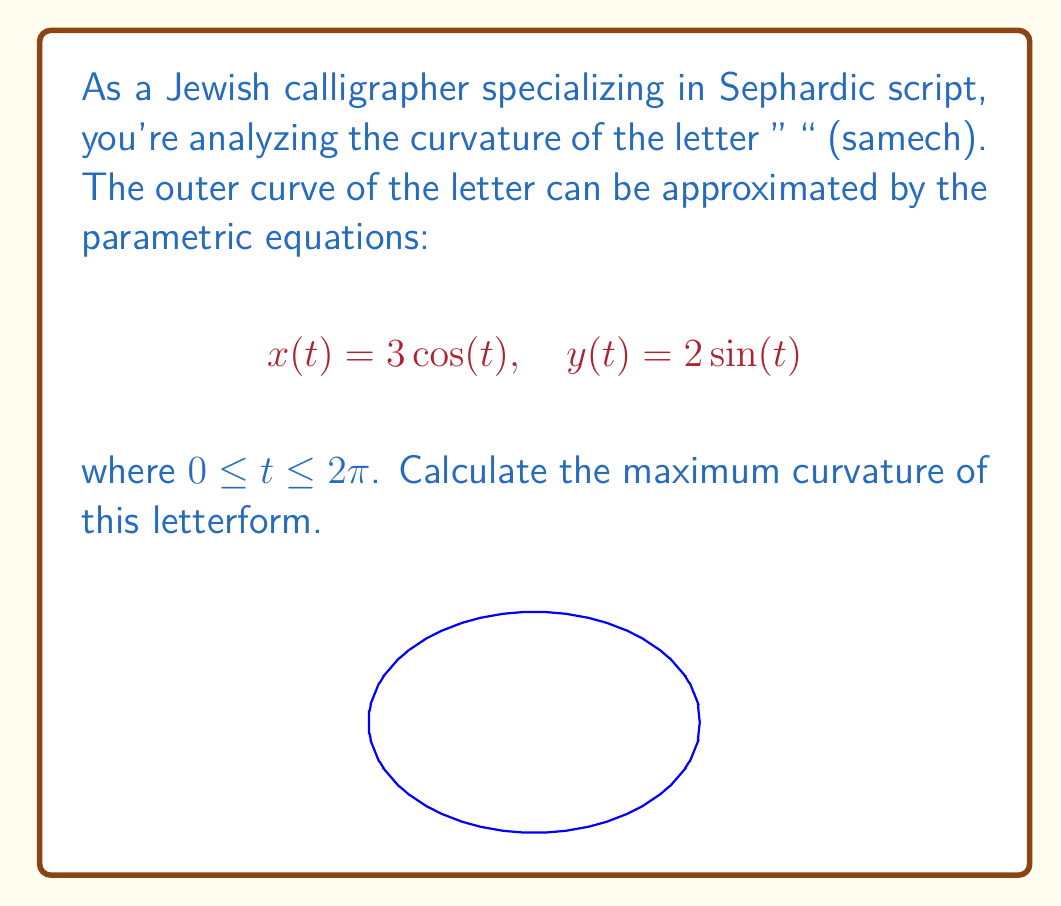Teach me how to tackle this problem. To find the maximum curvature, we'll follow these steps:

1) The curvature formula for parametric equations is:

   $$\kappa = \frac{|x'y'' - y'x''|}{(x'^2 + y'^2)^{3/2}}$$

2) Calculate the first derivatives:
   $$x'(t) = -3\sin(t), \quad y'(t) = 2\cos(t)$$

3) Calculate the second derivatives:
   $$x''(t) = -3\cos(t), \quad y''(t) = -2\sin(t)$$

4) Substitute into the curvature formula:

   $$\kappa = \frac{|(-3\sin(t))(-2\sin(t)) - (2\cos(t))(-3\cos(t))|}{((-3\sin(t))^2 + (2\cos(t))^2)^{3/2}}$$

5) Simplify:

   $$\kappa = \frac{|6\sin^2(t) + 6\cos^2(t)|}{(9\sin^2(t) + 4\cos^2(t))^{3/2}} = \frac{6}{(9\sin^2(t) + 4\cos^2(t))^{3/2}}$$

6) To find the maximum, we need to minimize the denominator. This occurs when $\sin^2(t) = 0$ and $\cos^2(t) = 1$.

7) Therefore, the maximum curvature is:

   $$\kappa_{max} = \frac{6}{4^{3/2}} = \frac{6}{8} = \frac{3}{4}$$
Answer: $\frac{3}{4}$ 